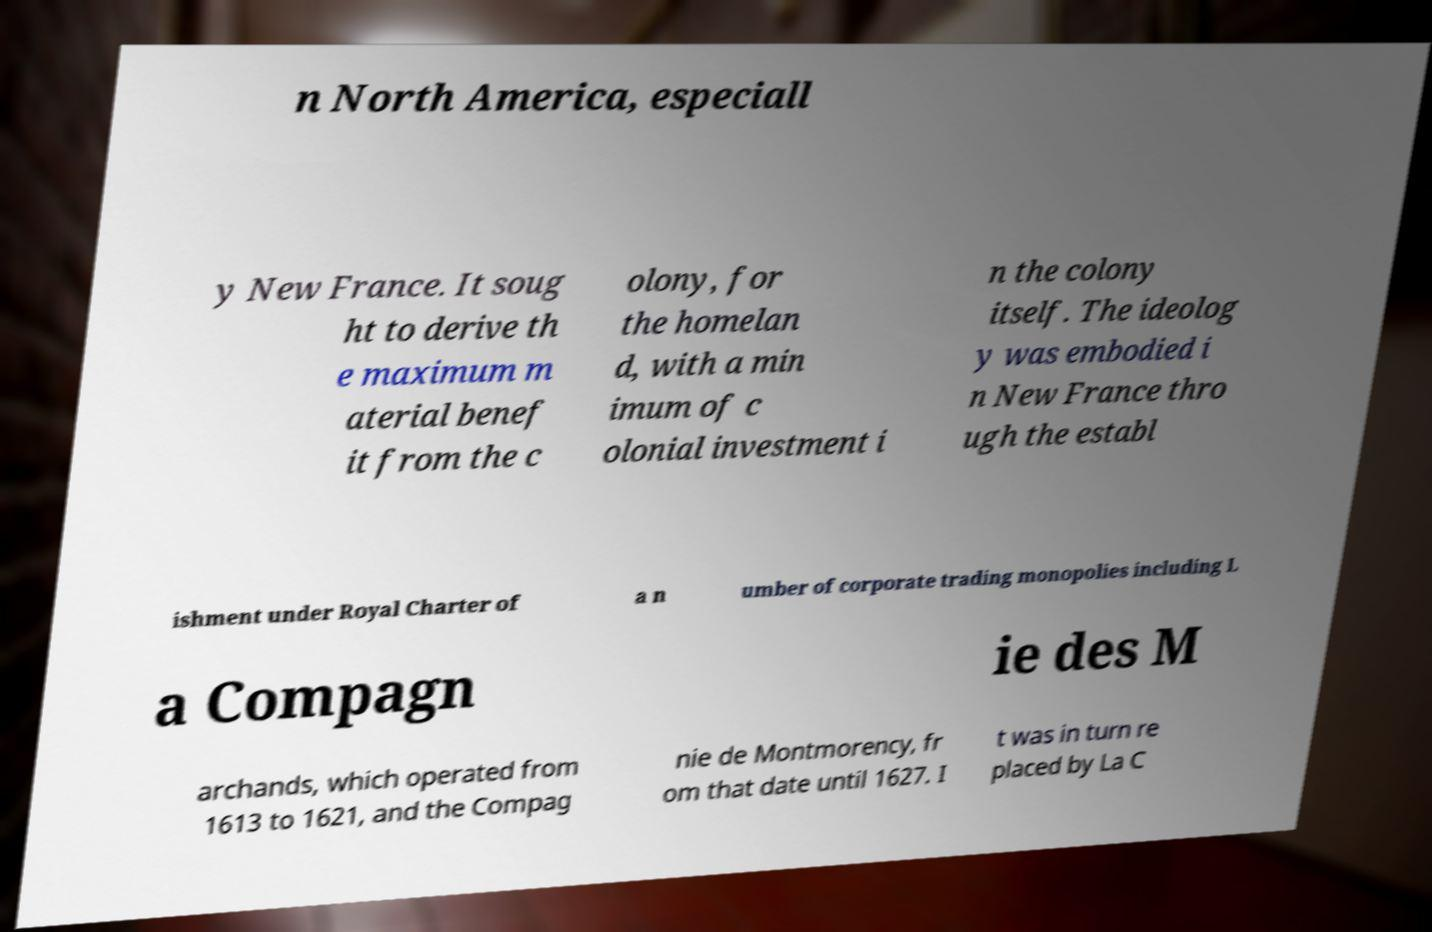I need the written content from this picture converted into text. Can you do that? n North America, especiall y New France. It soug ht to derive th e maximum m aterial benef it from the c olony, for the homelan d, with a min imum of c olonial investment i n the colony itself. The ideolog y was embodied i n New France thro ugh the establ ishment under Royal Charter of a n umber of corporate trading monopolies including L a Compagn ie des M archands, which operated from 1613 to 1621, and the Compag nie de Montmorency, fr om that date until 1627. I t was in turn re placed by La C 